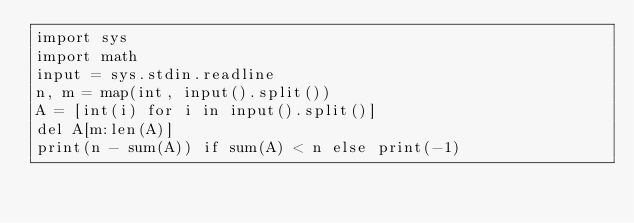Convert code to text. <code><loc_0><loc_0><loc_500><loc_500><_Python_>import sys
import math
input = sys.stdin.readline
n, m = map(int, input().split())
A = [int(i) for i in input().split()]
del A[m:len(A)]
print(n - sum(A)) if sum(A) < n else print(-1)
</code> 